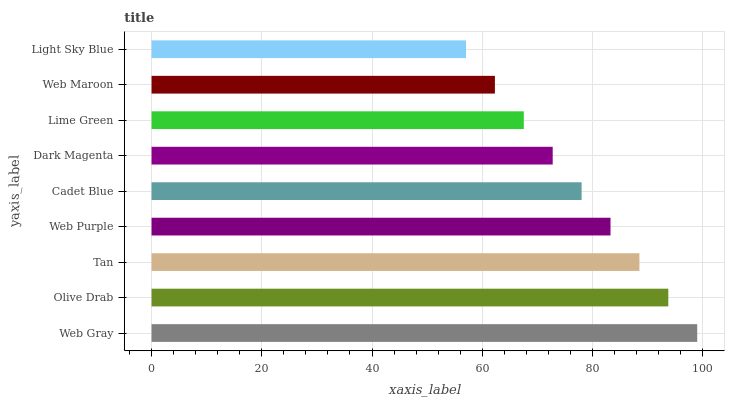Is Light Sky Blue the minimum?
Answer yes or no. Yes. Is Web Gray the maximum?
Answer yes or no. Yes. Is Olive Drab the minimum?
Answer yes or no. No. Is Olive Drab the maximum?
Answer yes or no. No. Is Web Gray greater than Olive Drab?
Answer yes or no. Yes. Is Olive Drab less than Web Gray?
Answer yes or no. Yes. Is Olive Drab greater than Web Gray?
Answer yes or no. No. Is Web Gray less than Olive Drab?
Answer yes or no. No. Is Cadet Blue the high median?
Answer yes or no. Yes. Is Cadet Blue the low median?
Answer yes or no. Yes. Is Web Maroon the high median?
Answer yes or no. No. Is Light Sky Blue the low median?
Answer yes or no. No. 